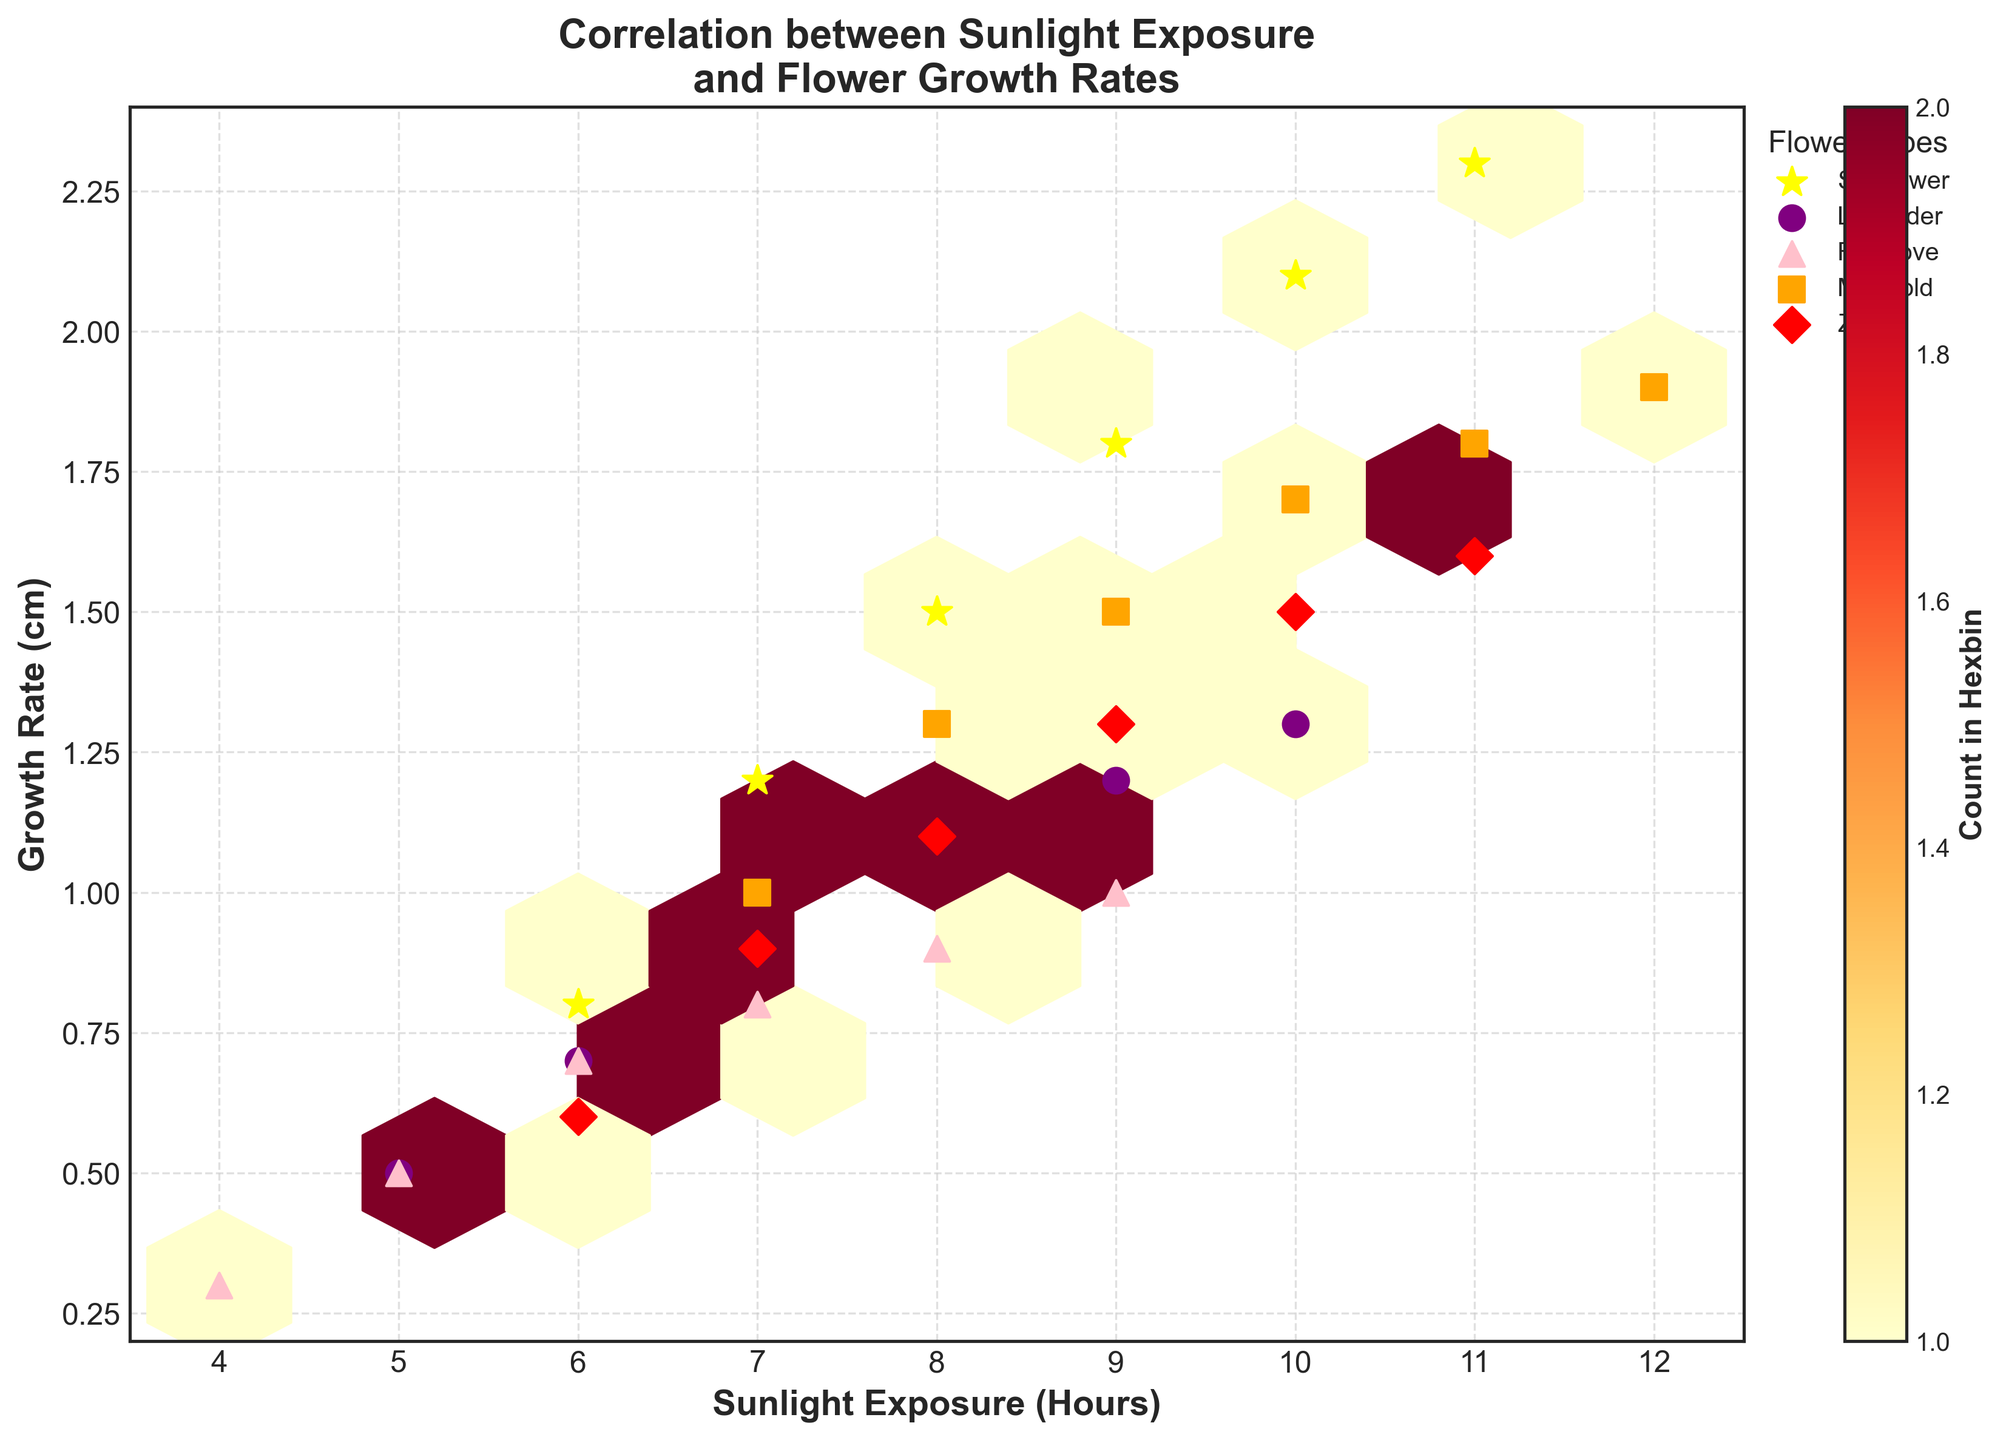What's the title of the plot? The title is located at the top of the plot. It reads, "Correlation between Sunlight Exposure and Flower Growth Rates."
Answer: Correlation between Sunlight Exposure and Flower Growth Rates What are the axis labels on the plot? The axis labels are the textual descriptions placed next to the horizontal and vertical axes. The x-axis label reads "Sunlight Exposure (Hours)" and the y-axis label reads "Growth Rate (cm)."
Answer: Sunlight Exposure (Hours), Growth Rate (cm) Which flower type shows the highest growth rate with the given sunlight exposure? By examining the scatter points on the plot, the yellow stars representing Sunflowers show the highest growth rate with increasing sunlight exposure, reaching up to 2.3 cm.
Answer: Sunflower How many hours of sunlight is required for a Zinnia to achieve a growth rate of at least 1.5 cm? By locating the red diamond markers representing Zinnias, we see that they achieve a growth rate of 1.5 cm with approximately 10 hours of sunlight.
Answer: 10 hours What is the most densely populated region in the hexbin plot? The color intensity in hexbin plots represents density. The yellow to red gradient shows us that the densest region is around 8-9 hours of sunlight and 1-1.5 cm growth rate.
Answer: Around 8-9 hours of sunlight and 1-1.5 cm growth rate What growth rate is associated with 7 hours of sunlight for Lavender? Look for purple circles representing Lavender. At 7 hours of sunlight, Lavender has a growth rate of 0.9 cm.
Answer: 0.9 cm Among the flower types, which one shows the least variation in growth rates based on sunlight exposure? By observing the spread of points for each flower type, Foxglove, represented by pink triangles, shows the least variation in growth rates across different sunlight exposures, ranging only from 0.3 to 1 cm.
Answer: Foxglove What is the approximate average growth rate for Marigolds with 10 hours of sunlight? Locate the orange squares for Marigolds at 10 hours of sunlight. The growth rate values at 10 hours of sunlight are around 1.7 cm.
Answer: 1.7 cm Compare the growth rates of Foxglove and Zinnia at 9 hours of sunlight. Which one grows faster and by how much? The pink triangles for Foxgloves show a growth rate of 1.0 cm at 9 hours, while the red diamonds for Zinnias show a growth rate of 1.3 cm at the same sunlight. Zinnia grows faster by 0.3 cm.
Answer: Zinnia grows faster by 0.3 cm 